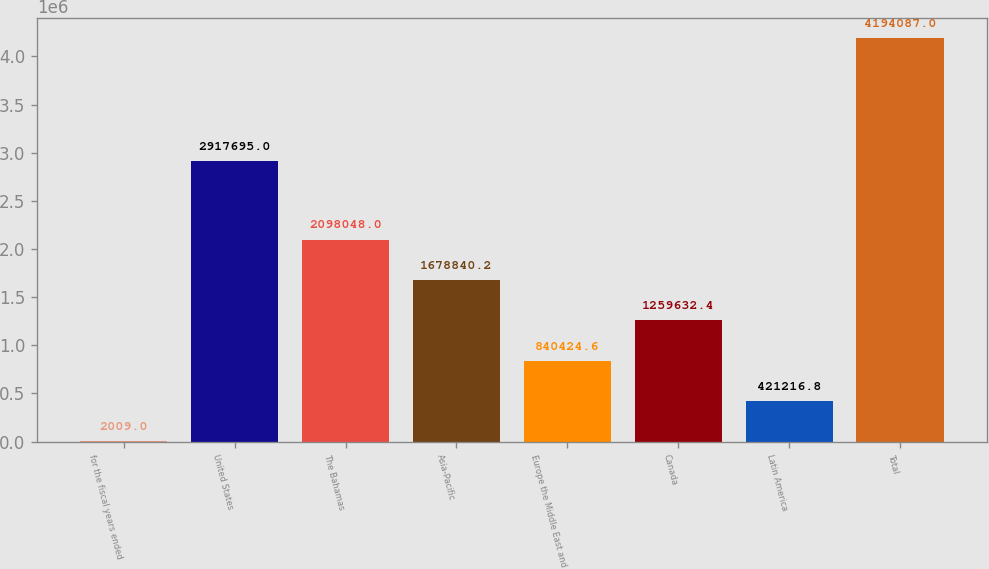<chart> <loc_0><loc_0><loc_500><loc_500><bar_chart><fcel>for the fiscal years ended<fcel>United States<fcel>The Bahamas<fcel>Asia-Pacific<fcel>Europe the Middle East and<fcel>Canada<fcel>Latin America<fcel>Total<nl><fcel>2009<fcel>2.9177e+06<fcel>2.09805e+06<fcel>1.67884e+06<fcel>840425<fcel>1.25963e+06<fcel>421217<fcel>4.19409e+06<nl></chart> 